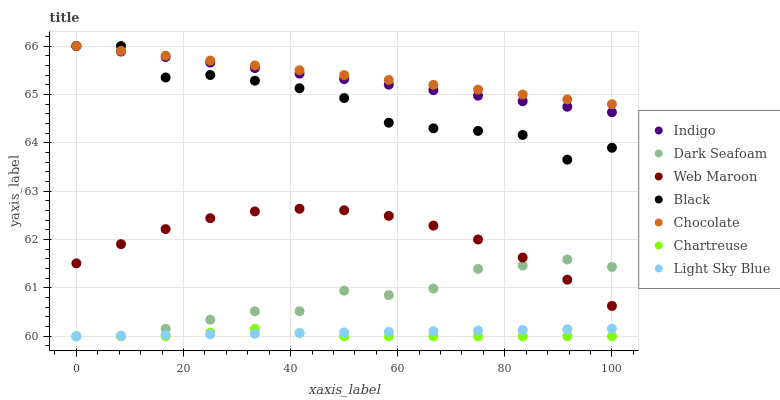Does Chartreuse have the minimum area under the curve?
Answer yes or no. Yes. Does Chocolate have the maximum area under the curve?
Answer yes or no. Yes. Does Web Maroon have the minimum area under the curve?
Answer yes or no. No. Does Web Maroon have the maximum area under the curve?
Answer yes or no. No. Is Light Sky Blue the smoothest?
Answer yes or no. Yes. Is Black the roughest?
Answer yes or no. Yes. Is Web Maroon the smoothest?
Answer yes or no. No. Is Web Maroon the roughest?
Answer yes or no. No. Does Chartreuse have the lowest value?
Answer yes or no. Yes. Does Web Maroon have the lowest value?
Answer yes or no. No. Does Black have the highest value?
Answer yes or no. Yes. Does Web Maroon have the highest value?
Answer yes or no. No. Is Web Maroon less than Black?
Answer yes or no. Yes. Is Chocolate greater than Web Maroon?
Answer yes or no. Yes. Does Indigo intersect Black?
Answer yes or no. Yes. Is Indigo less than Black?
Answer yes or no. No. Is Indigo greater than Black?
Answer yes or no. No. Does Web Maroon intersect Black?
Answer yes or no. No. 